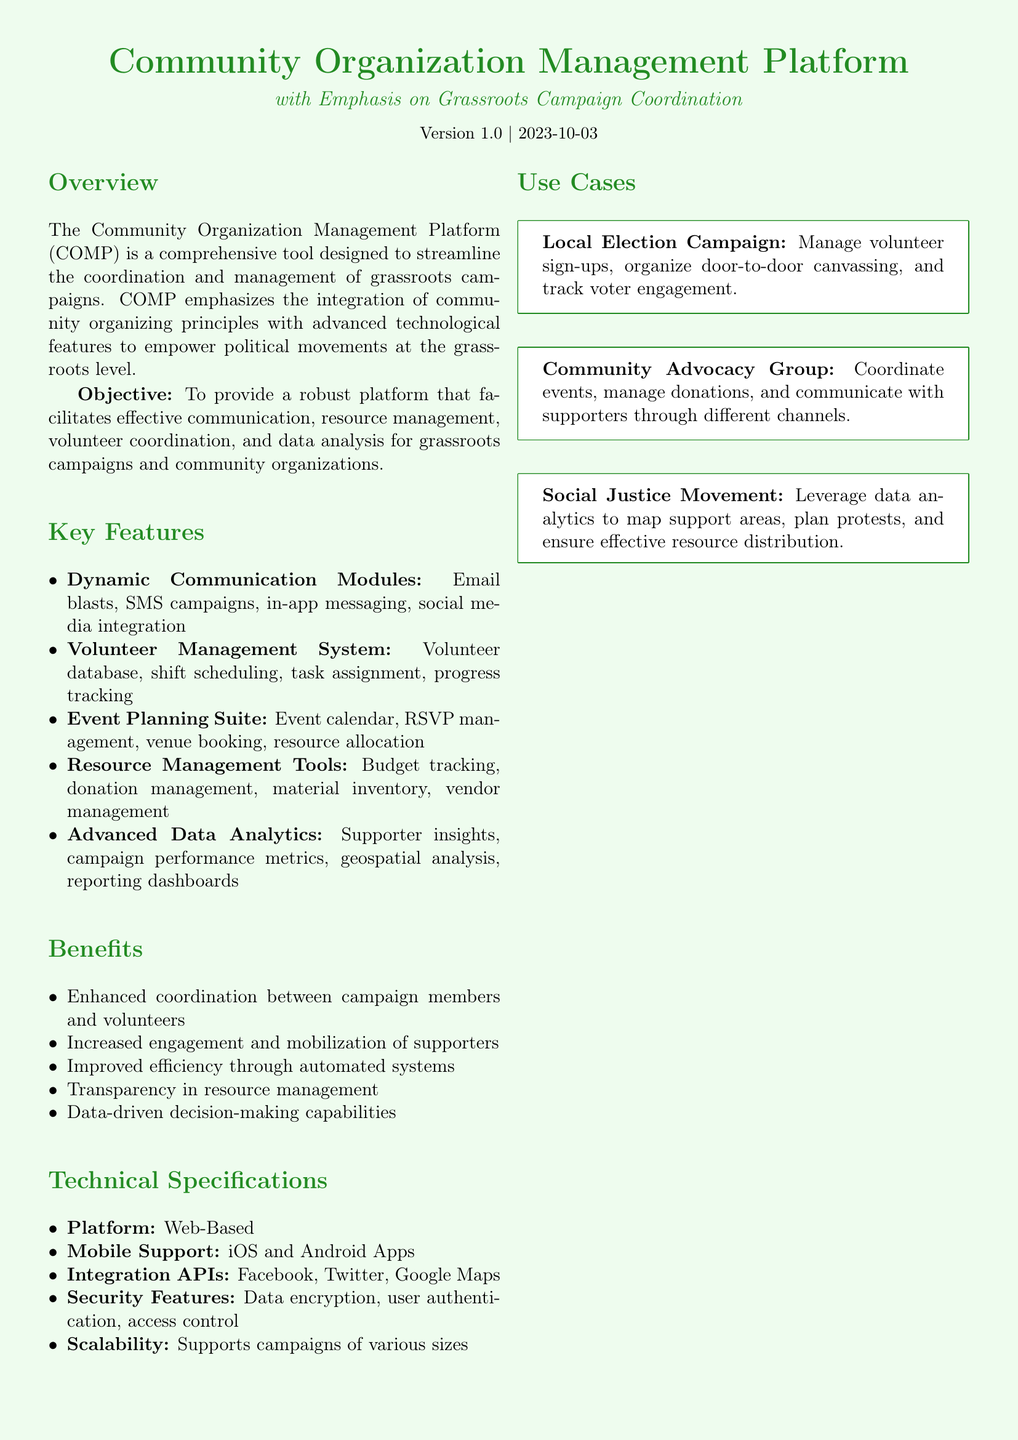What is the version number of the platform? The version number is explicitly stated in the document.
Answer: 1.0 What is the primary objective of the Community Organization Management Platform? The objective is clearly mentioned in the Overview section.
Answer: To provide a robust platform that facilitates effective communication, resource management, volunteer coordination, and data analysis for grassroots campaigns and community organizations How many key features does the platform have? The document lists several features which can be counted.
Answer: Five What mobile platforms are supported by the Community Organization Management Platform? The supported mobile platforms are specified in the Technical Specifications.
Answer: iOS and Android What is one use case mentioned for the platform? The document presents specific examples in the Use Cases section.
Answer: Local Election Campaign What kind of data security features does the platform provide? Information about security features is found in the Technical Specifications section.
Answer: Data encryption, user authentication, access control What is one benefit of using the Community Organization Management Platform? Benefits of the platform are listed in the Benefits section.
Answer: Enhanced coordination between campaign members and volunteers What type of communication does the platform support? This is detailed under the Key Features section regarding communication modules.
Answer: Email blasts, SMS campaigns, in-app messaging, social media integration What color is used for the document's title? The document specifies the color used for the title.
Answer: Grassgreen 